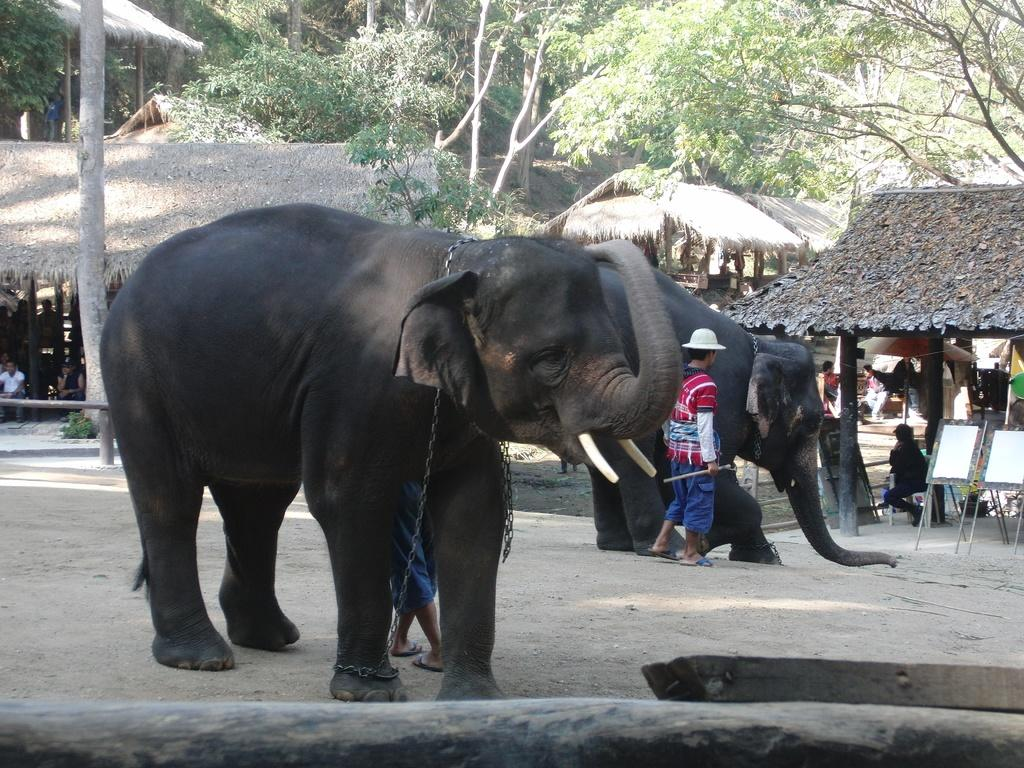What animals can be seen in the image? There are elephants in the image. Who or what else is present in the image? There is a person standing in the image. What type of structures are visible in the image? There are huts in the image. What natural element is present in the image? There is a tree in the image. Where is the nest located in the image? There is no nest present in the image. How does the person in the image take a bath? The image does not show the person taking a bath, so it cannot be determined from the image. 